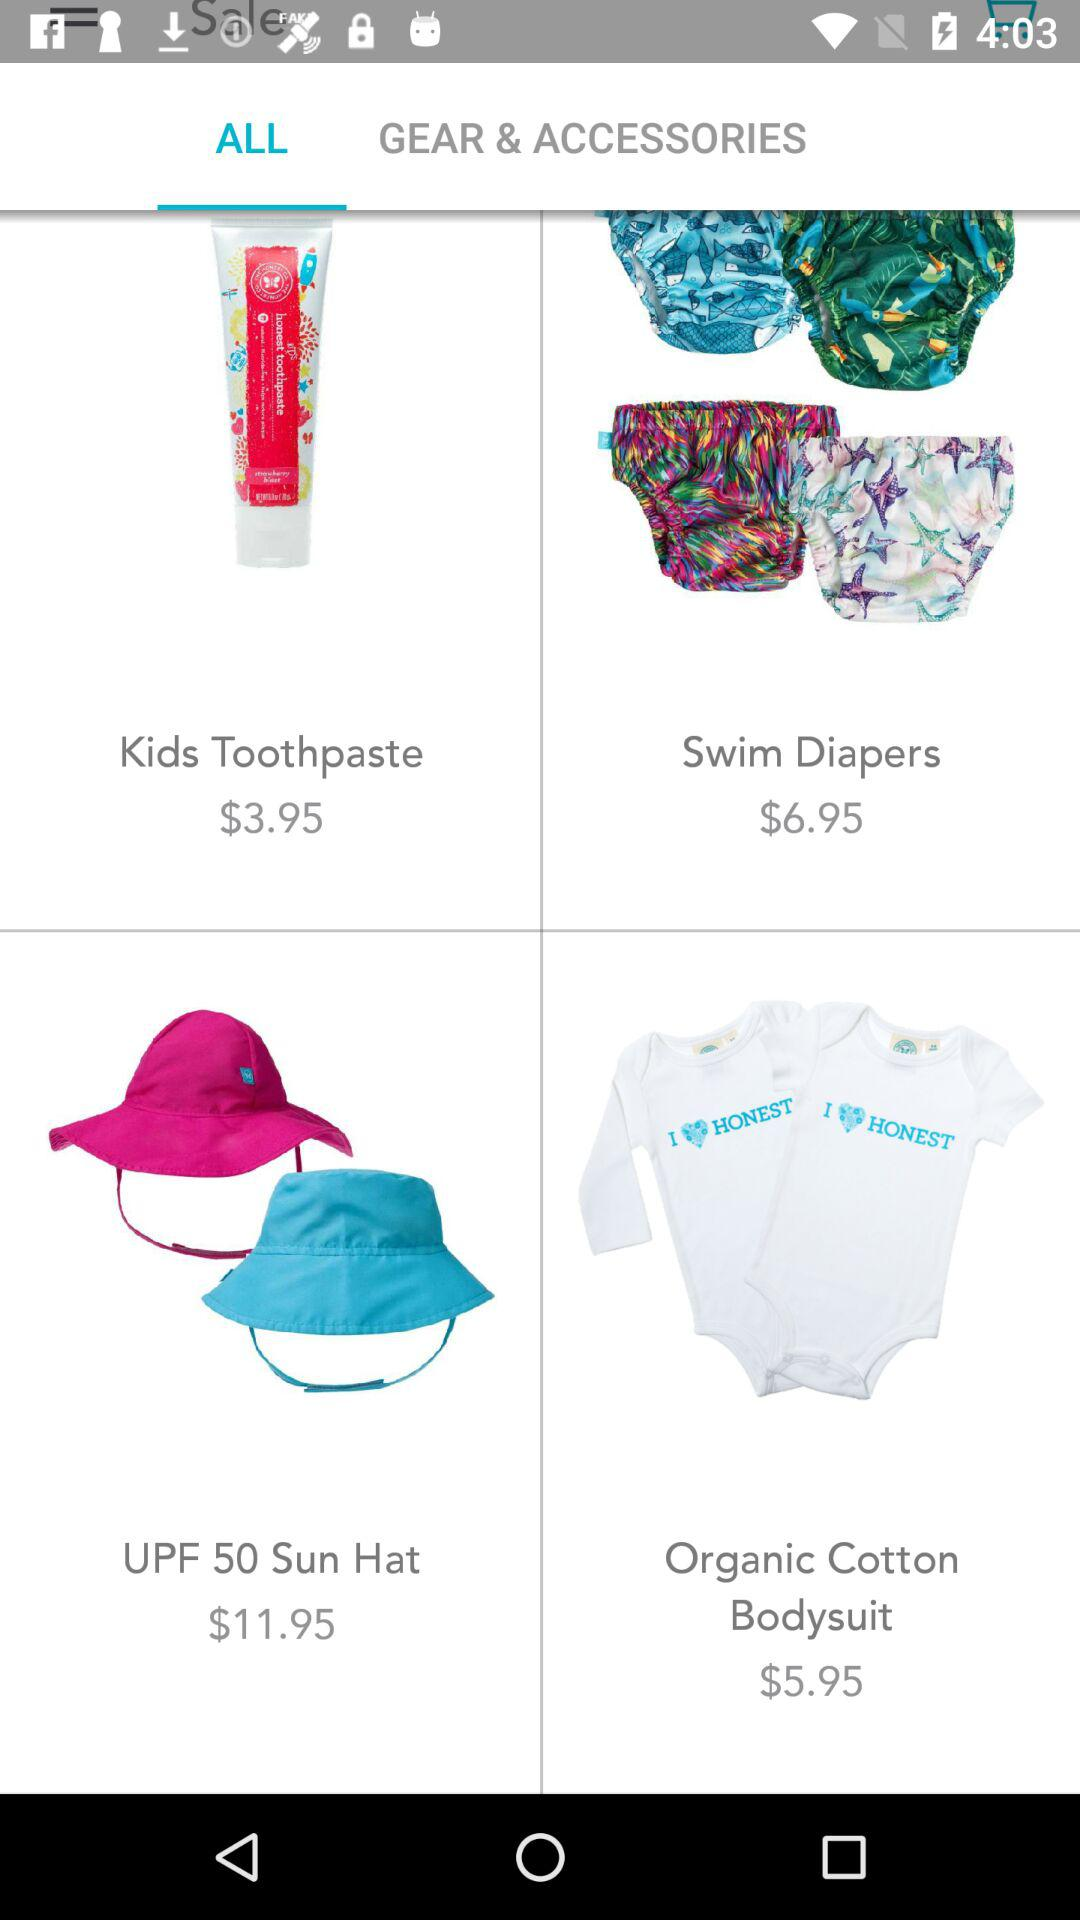Which tab are we on? You are on the "ALL" tab. 